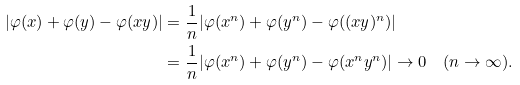Convert formula to latex. <formula><loc_0><loc_0><loc_500><loc_500>| \varphi ( x ) + \varphi ( y ) - \varphi ( x y ) | & = \frac { 1 } { n } | \varphi ( x ^ { n } ) + \varphi ( y ^ { n } ) - \varphi ( ( x y ) ^ { n } ) | \\ & = \frac { 1 } { n } | \varphi ( x ^ { n } ) + \varphi ( y ^ { n } ) - \varphi ( x ^ { n } y ^ { n } ) | \rightarrow 0 \quad ( n \rightarrow \infty ) .</formula> 